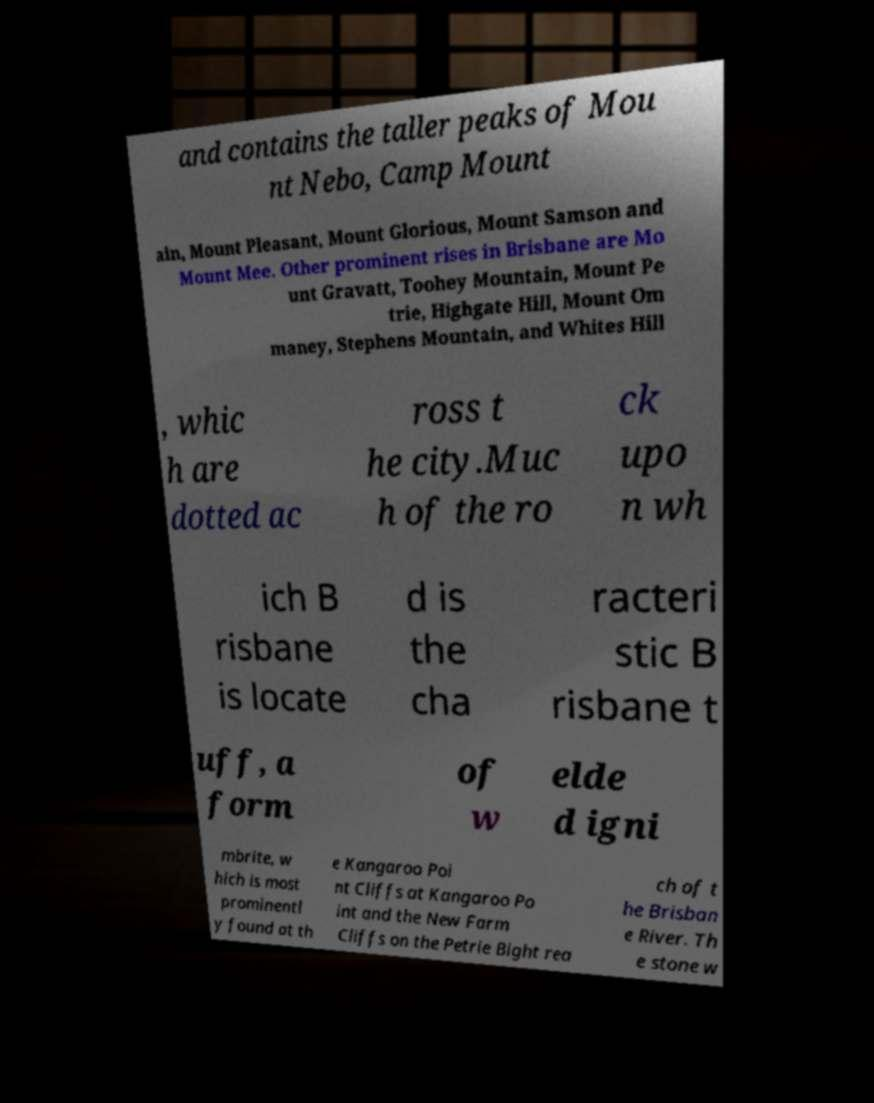Please read and relay the text visible in this image. What does it say? and contains the taller peaks of Mou nt Nebo, Camp Mount ain, Mount Pleasant, Mount Glorious, Mount Samson and Mount Mee. Other prominent rises in Brisbane are Mo unt Gravatt, Toohey Mountain, Mount Pe trie, Highgate Hill, Mount Om maney, Stephens Mountain, and Whites Hill , whic h are dotted ac ross t he city.Muc h of the ro ck upo n wh ich B risbane is locate d is the cha racteri stic B risbane t uff, a form of w elde d igni mbrite, w hich is most prominentl y found at th e Kangaroo Poi nt Cliffs at Kangaroo Po int and the New Farm Cliffs on the Petrie Bight rea ch of t he Brisban e River. Th e stone w 